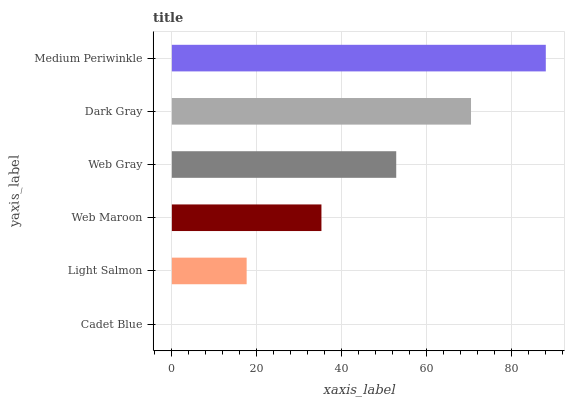Is Cadet Blue the minimum?
Answer yes or no. Yes. Is Medium Periwinkle the maximum?
Answer yes or no. Yes. Is Light Salmon the minimum?
Answer yes or no. No. Is Light Salmon the maximum?
Answer yes or no. No. Is Light Salmon greater than Cadet Blue?
Answer yes or no. Yes. Is Cadet Blue less than Light Salmon?
Answer yes or no. Yes. Is Cadet Blue greater than Light Salmon?
Answer yes or no. No. Is Light Salmon less than Cadet Blue?
Answer yes or no. No. Is Web Gray the high median?
Answer yes or no. Yes. Is Web Maroon the low median?
Answer yes or no. Yes. Is Medium Periwinkle the high median?
Answer yes or no. No. Is Web Gray the low median?
Answer yes or no. No. 